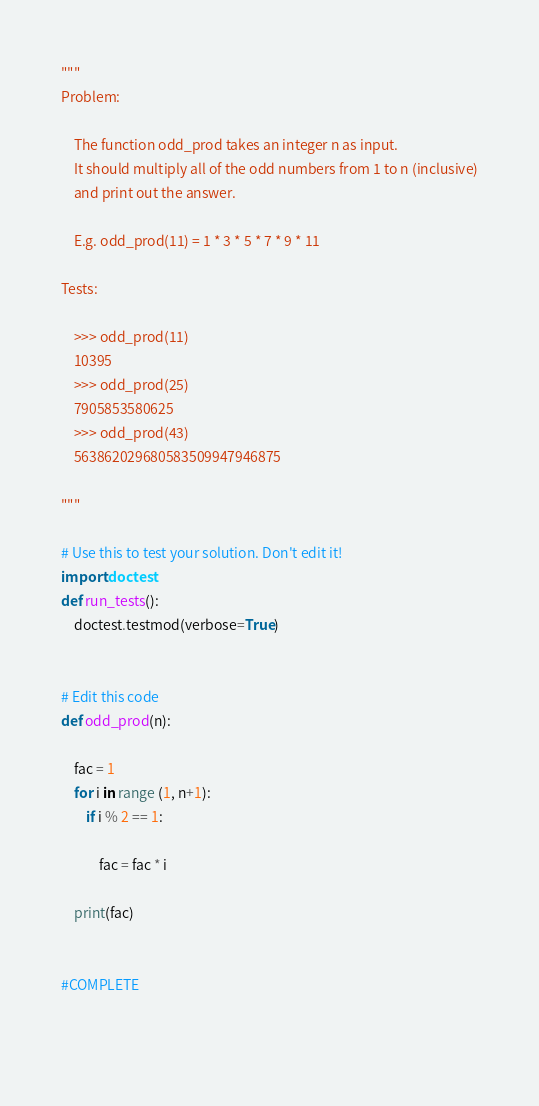<code> <loc_0><loc_0><loc_500><loc_500><_Python_>"""
Problem:

    The function odd_prod takes an integer n as input.
    It should multiply all of the odd numbers from 1 to n (inclusive)
    and print out the answer.

    E.g. odd_prod(11) = 1 * 3 * 5 * 7 * 9 * 11

Tests:

    >>> odd_prod(11)
    10395
    >>> odd_prod(25)
    7905853580625
    >>> odd_prod(43)
    563862029680583509947946875

"""

# Use this to test your solution. Don't edit it!
import doctest
def run_tests():
    doctest.testmod(verbose=True)


# Edit this code
def odd_prod(n):

    fac = 1
    for i in range (1, n+1):
        if i % 2 == 1:
        
            fac = fac * i

    print(fac)


#COMPLETE

            


</code> 